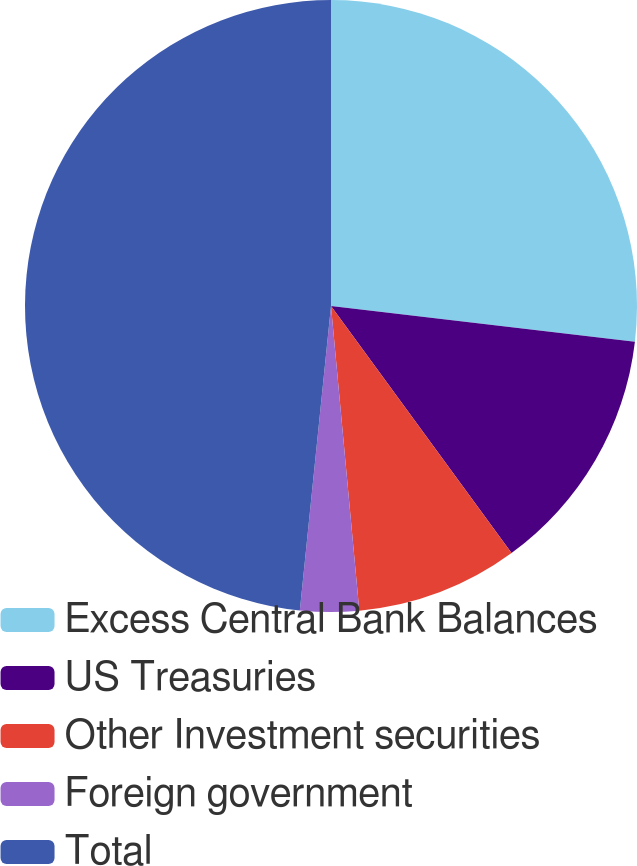<chart> <loc_0><loc_0><loc_500><loc_500><pie_chart><fcel>Excess Central Bank Balances<fcel>US Treasuries<fcel>Other Investment securities<fcel>Foreign government<fcel>Total<nl><fcel>26.86%<fcel>13.1%<fcel>8.57%<fcel>3.1%<fcel>48.38%<nl></chart> 